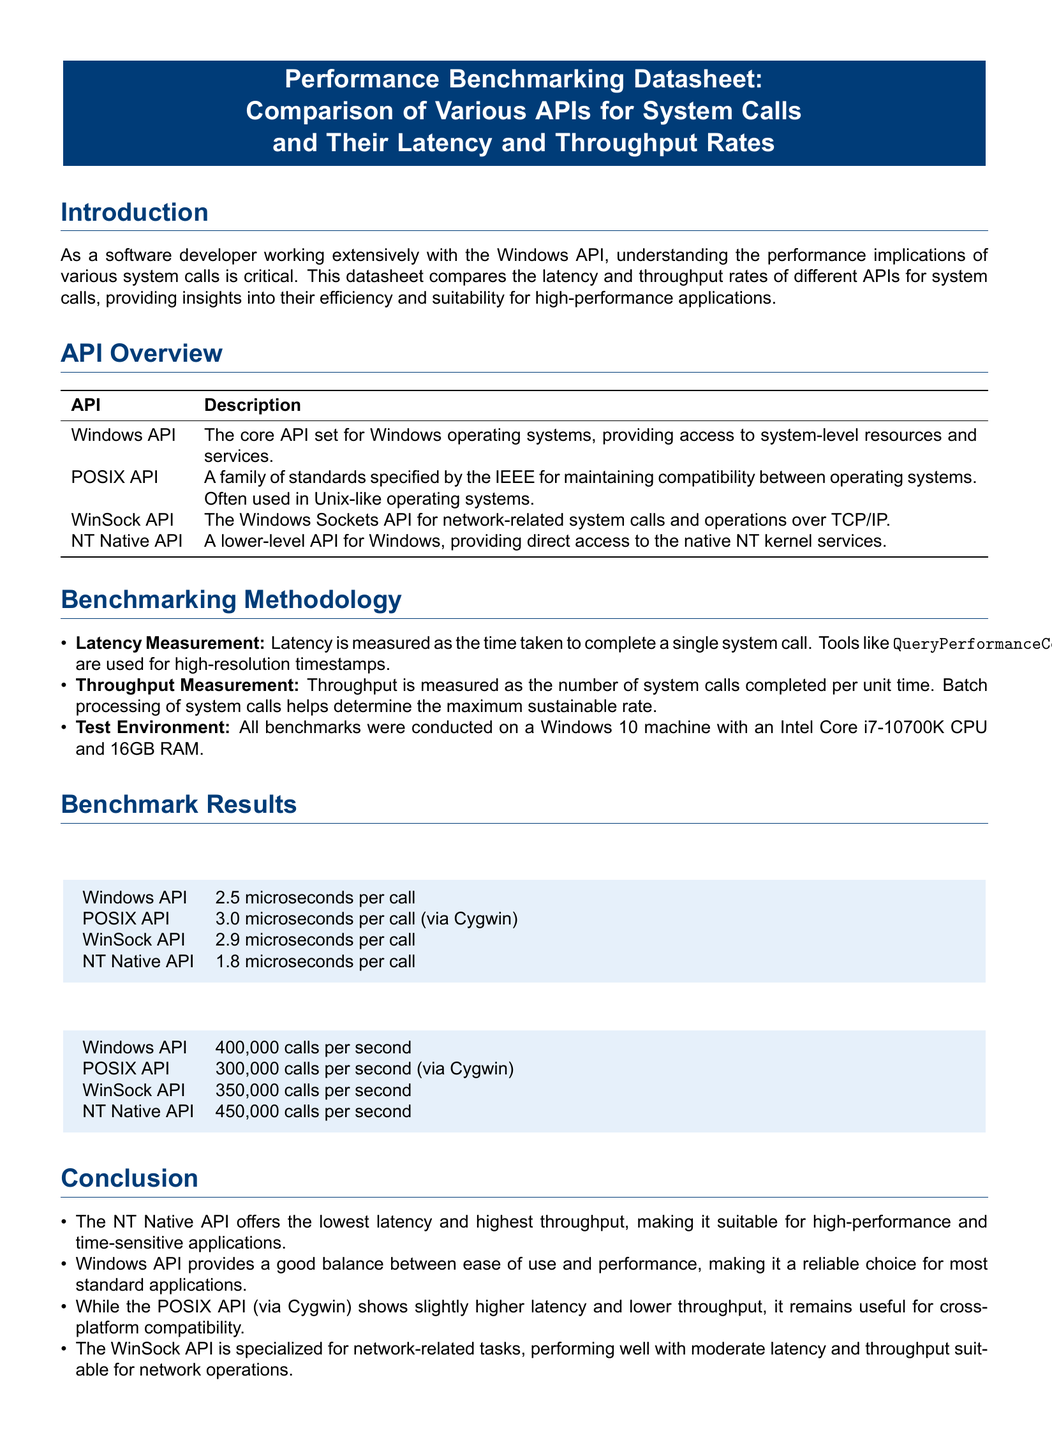What is the latency for the NT Native API? The latency for the NT Native API is specified in the Benchmark Results section as 1.8 microseconds per call.
Answer: 1.8 microseconds per call What is the maximum throughput of the Windows API? The maximum throughput for the Windows API is given in the Benchmark Results section as 400,000 calls per second.
Answer: 400,000 calls per second Which API has the highest throughput? The API with the highest throughput, as stated in the Benchmark Results section, is the NT Native API at 450,000 calls per second.
Answer: NT Native API What is the latency of the POSIX API? The latency of the POSIX API is mentioned in the Benchmark Results section as 3.0 microseconds per call (via Cygwin).
Answer: 3.0 microseconds per call What type of API is the WinSock API? The WinSock API is specified in the API Overview as the Windows Sockets API for network-related system calls.
Answer: Network-related system calls Which API is recommended for high-performance applications? The conclusion states that the NT Native API is recommended for high-performance and time-sensitive applications due to its low latency and high throughput.
Answer: NT Native API 